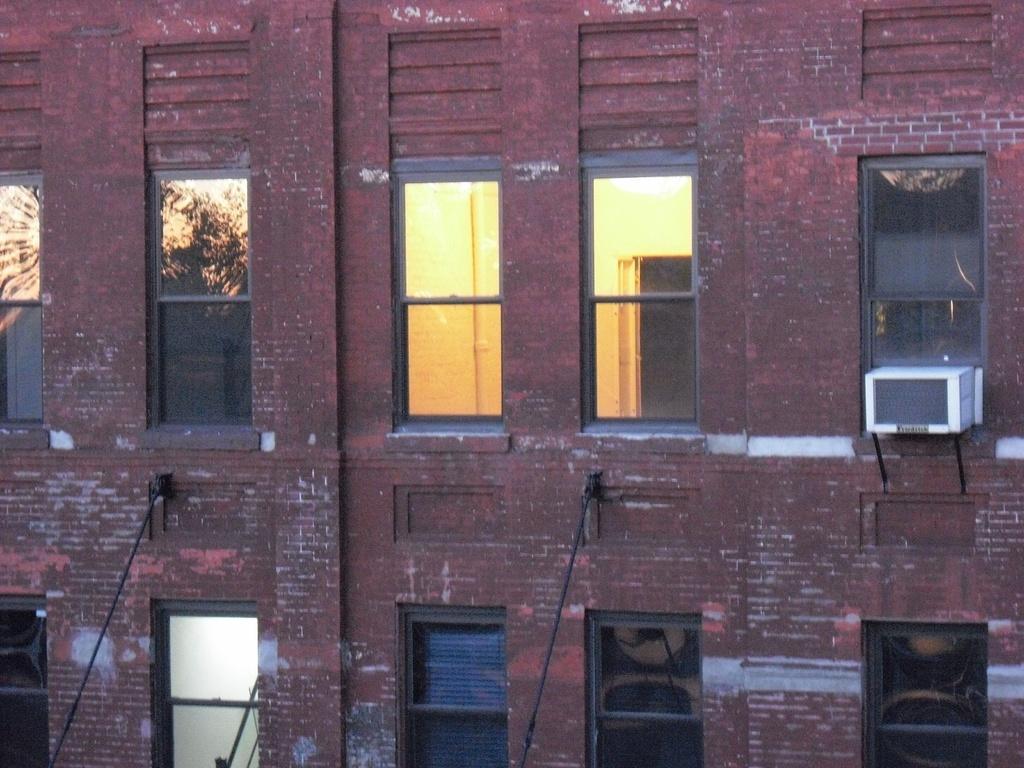Describe this image in one or two sentences. This is the picture of a building. In this image there is a building. There is a reflection of sky and tree on the window. There are lights inside the building. 